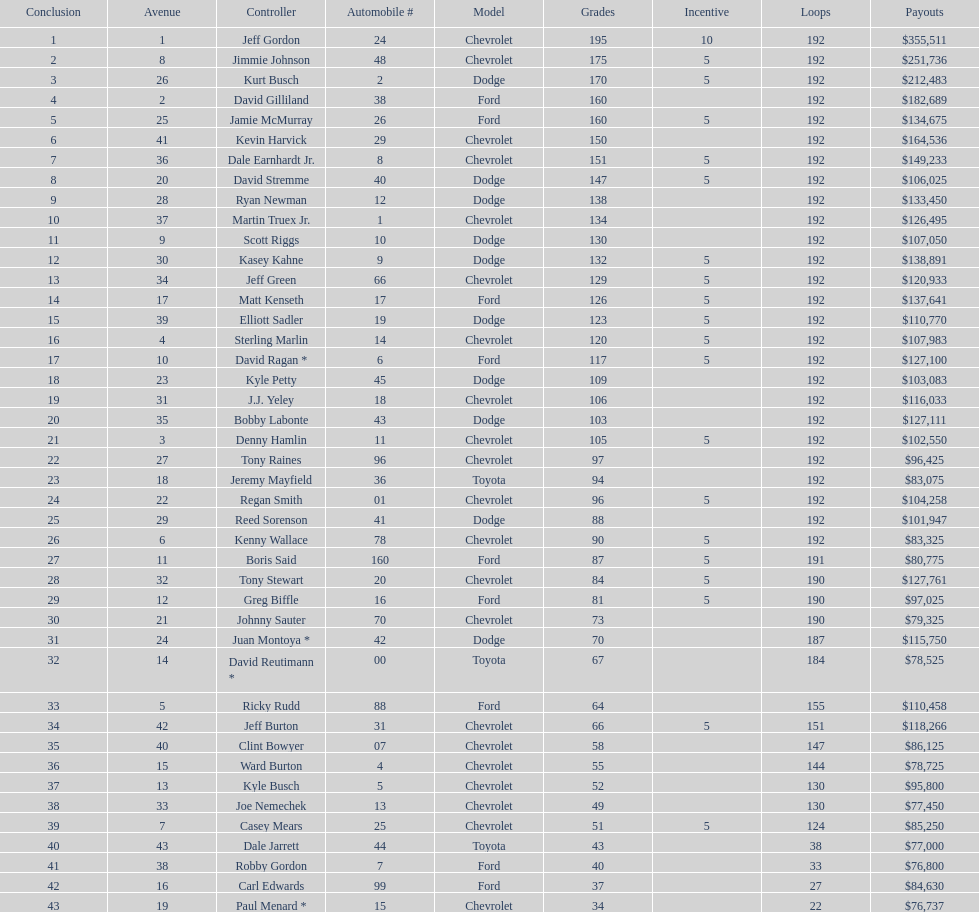Which make had the most consecutive finishes at the aarons 499? Chevrolet. 